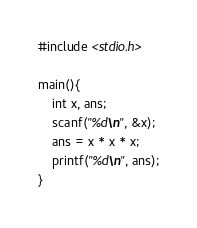<code> <loc_0><loc_0><loc_500><loc_500><_C_>#include <stdio.h>

main(){
	int x, ans;
	scanf("%d\n", &x);
	ans = x * x * x;
	printf("%d\n", ans);
}</code> 